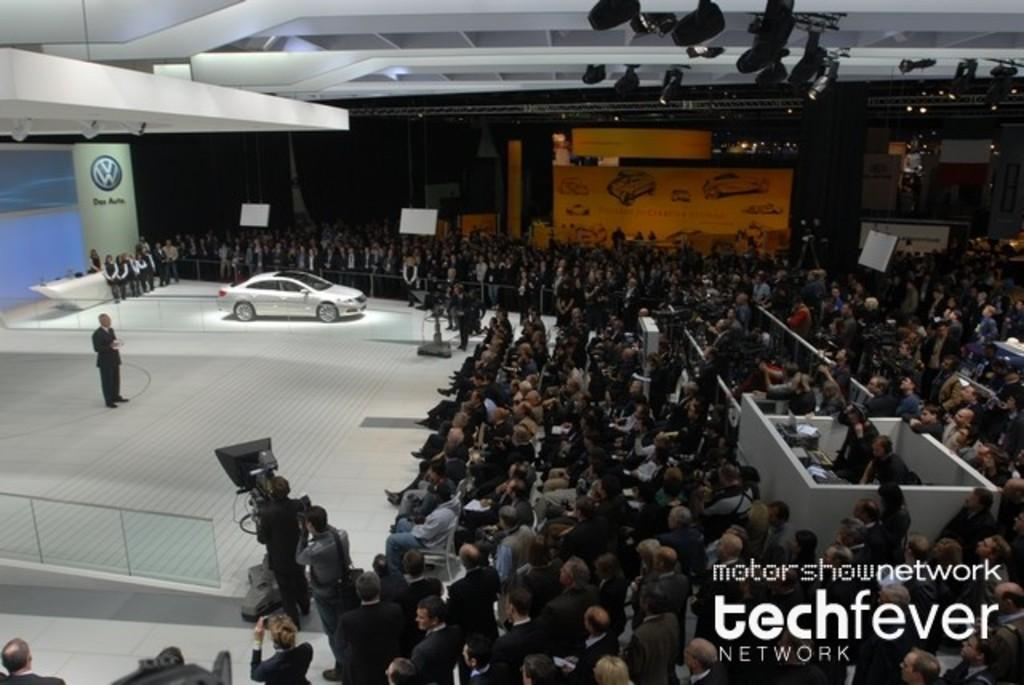Where was the image taken? The image was taken inside a showroom. How many people can be seen in the image? There are multiple people standing in the image. What is the main subject of the image? There is a car in the middle of the image. What can be seen at the top of the image? There are lights visible at the top of the image. What type of soda is being served to the people in the image? There is no soda present in the image. What nation is represented by the people in the image? The image does not provide information about the nationality of the people. 